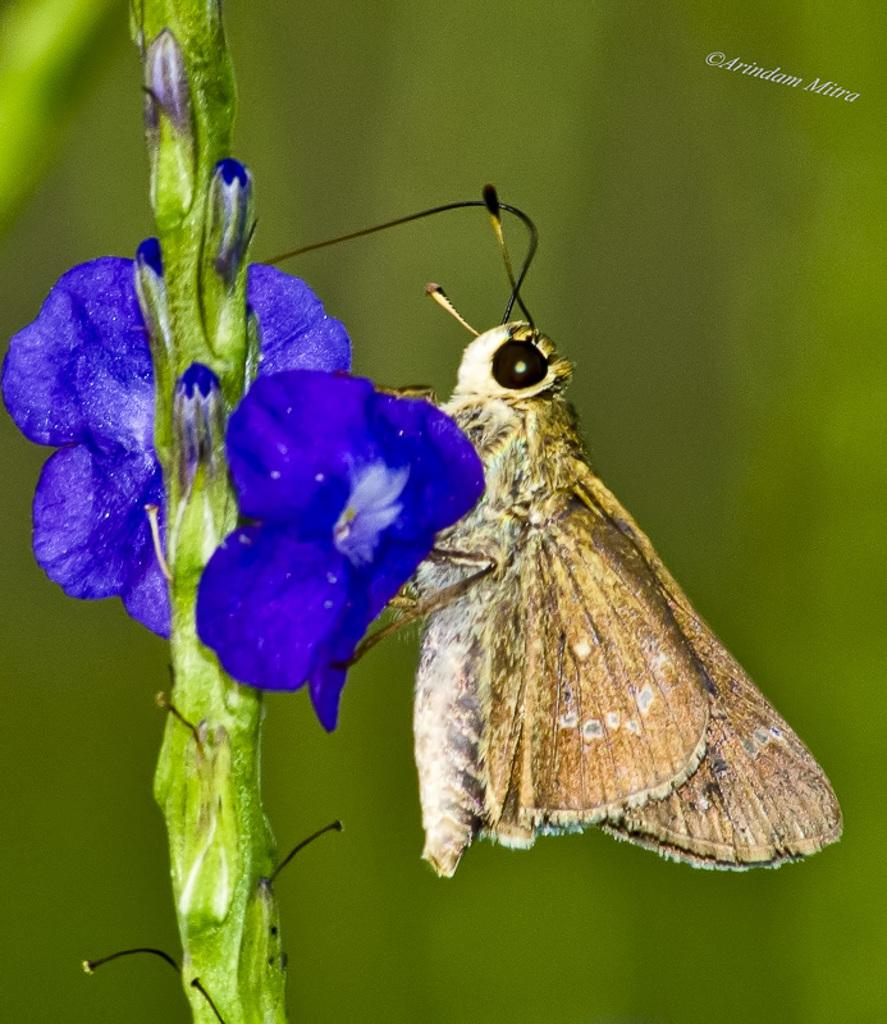What is on the flowers in the image? There is a butterfly on the flowers in the image. What part of the plant can be seen in the image? There is a plant stem visible in the image. Is there any text or marking in the image? Yes, there is a watermark in the top right corner of the image. What type of furniture can be seen in the image? There is no furniture present in the image; it features a butterfly on flowers and a plant stem. 